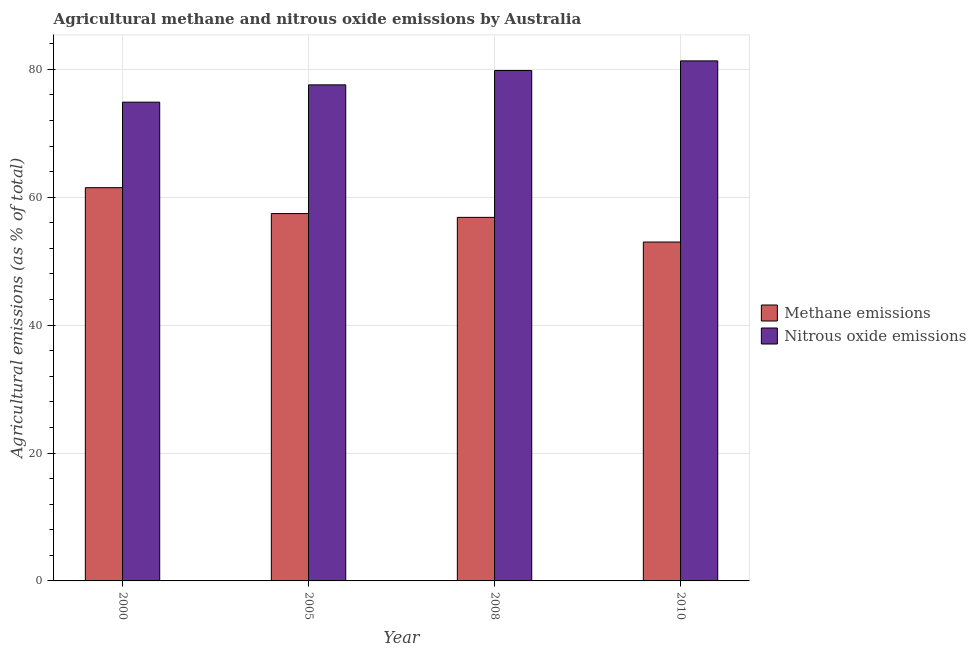Are the number of bars on each tick of the X-axis equal?
Your answer should be compact. Yes. How many bars are there on the 2nd tick from the left?
Your answer should be very brief. 2. How many bars are there on the 2nd tick from the right?
Keep it short and to the point. 2. What is the amount of nitrous oxide emissions in 2000?
Provide a short and direct response. 74.87. Across all years, what is the maximum amount of methane emissions?
Give a very brief answer. 61.5. Across all years, what is the minimum amount of nitrous oxide emissions?
Offer a terse response. 74.87. In which year was the amount of nitrous oxide emissions maximum?
Make the answer very short. 2010. What is the total amount of nitrous oxide emissions in the graph?
Ensure brevity in your answer.  313.6. What is the difference between the amount of methane emissions in 2005 and that in 2010?
Your answer should be compact. 4.45. What is the difference between the amount of nitrous oxide emissions in 2005 and the amount of methane emissions in 2010?
Your response must be concise. -3.75. What is the average amount of nitrous oxide emissions per year?
Keep it short and to the point. 78.4. In how many years, is the amount of nitrous oxide emissions greater than 48 %?
Keep it short and to the point. 4. What is the ratio of the amount of methane emissions in 2000 to that in 2008?
Keep it short and to the point. 1.08. Is the difference between the amount of methane emissions in 2008 and 2010 greater than the difference between the amount of nitrous oxide emissions in 2008 and 2010?
Ensure brevity in your answer.  No. What is the difference between the highest and the second highest amount of nitrous oxide emissions?
Ensure brevity in your answer.  1.51. What is the difference between the highest and the lowest amount of methane emissions?
Your response must be concise. 8.5. Is the sum of the amount of nitrous oxide emissions in 2000 and 2008 greater than the maximum amount of methane emissions across all years?
Your answer should be very brief. Yes. What does the 1st bar from the left in 2008 represents?
Give a very brief answer. Methane emissions. What does the 1st bar from the right in 2008 represents?
Give a very brief answer. Nitrous oxide emissions. How many bars are there?
Your response must be concise. 8. How many years are there in the graph?
Ensure brevity in your answer.  4. Are the values on the major ticks of Y-axis written in scientific E-notation?
Make the answer very short. No. Where does the legend appear in the graph?
Your answer should be compact. Center right. What is the title of the graph?
Provide a succinct answer. Agricultural methane and nitrous oxide emissions by Australia. Does "Resident" appear as one of the legend labels in the graph?
Give a very brief answer. No. What is the label or title of the Y-axis?
Keep it short and to the point. Agricultural emissions (as % of total). What is the Agricultural emissions (as % of total) of Methane emissions in 2000?
Your response must be concise. 61.5. What is the Agricultural emissions (as % of total) in Nitrous oxide emissions in 2000?
Give a very brief answer. 74.87. What is the Agricultural emissions (as % of total) of Methane emissions in 2005?
Ensure brevity in your answer.  57.45. What is the Agricultural emissions (as % of total) in Nitrous oxide emissions in 2005?
Provide a succinct answer. 77.58. What is the Agricultural emissions (as % of total) of Methane emissions in 2008?
Offer a terse response. 56.85. What is the Agricultural emissions (as % of total) in Nitrous oxide emissions in 2008?
Offer a terse response. 79.82. What is the Agricultural emissions (as % of total) in Methane emissions in 2010?
Keep it short and to the point. 53. What is the Agricultural emissions (as % of total) of Nitrous oxide emissions in 2010?
Your response must be concise. 81.33. Across all years, what is the maximum Agricultural emissions (as % of total) of Methane emissions?
Provide a succinct answer. 61.5. Across all years, what is the maximum Agricultural emissions (as % of total) in Nitrous oxide emissions?
Keep it short and to the point. 81.33. Across all years, what is the minimum Agricultural emissions (as % of total) of Methane emissions?
Your answer should be very brief. 53. Across all years, what is the minimum Agricultural emissions (as % of total) in Nitrous oxide emissions?
Your answer should be very brief. 74.87. What is the total Agricultural emissions (as % of total) of Methane emissions in the graph?
Your response must be concise. 228.8. What is the total Agricultural emissions (as % of total) of Nitrous oxide emissions in the graph?
Offer a terse response. 313.6. What is the difference between the Agricultural emissions (as % of total) of Methane emissions in 2000 and that in 2005?
Your answer should be very brief. 4.04. What is the difference between the Agricultural emissions (as % of total) in Nitrous oxide emissions in 2000 and that in 2005?
Ensure brevity in your answer.  -2.71. What is the difference between the Agricultural emissions (as % of total) of Methane emissions in 2000 and that in 2008?
Provide a succinct answer. 4.64. What is the difference between the Agricultural emissions (as % of total) of Nitrous oxide emissions in 2000 and that in 2008?
Provide a succinct answer. -4.95. What is the difference between the Agricultural emissions (as % of total) in Methane emissions in 2000 and that in 2010?
Give a very brief answer. 8.5. What is the difference between the Agricultural emissions (as % of total) of Nitrous oxide emissions in 2000 and that in 2010?
Provide a succinct answer. -6.46. What is the difference between the Agricultural emissions (as % of total) of Methane emissions in 2005 and that in 2008?
Provide a succinct answer. 0.6. What is the difference between the Agricultural emissions (as % of total) in Nitrous oxide emissions in 2005 and that in 2008?
Give a very brief answer. -2.24. What is the difference between the Agricultural emissions (as % of total) of Methane emissions in 2005 and that in 2010?
Give a very brief answer. 4.45. What is the difference between the Agricultural emissions (as % of total) of Nitrous oxide emissions in 2005 and that in 2010?
Offer a very short reply. -3.75. What is the difference between the Agricultural emissions (as % of total) of Methane emissions in 2008 and that in 2010?
Give a very brief answer. 3.86. What is the difference between the Agricultural emissions (as % of total) of Nitrous oxide emissions in 2008 and that in 2010?
Your answer should be compact. -1.51. What is the difference between the Agricultural emissions (as % of total) of Methane emissions in 2000 and the Agricultural emissions (as % of total) of Nitrous oxide emissions in 2005?
Your answer should be very brief. -16.08. What is the difference between the Agricultural emissions (as % of total) in Methane emissions in 2000 and the Agricultural emissions (as % of total) in Nitrous oxide emissions in 2008?
Your response must be concise. -18.32. What is the difference between the Agricultural emissions (as % of total) in Methane emissions in 2000 and the Agricultural emissions (as % of total) in Nitrous oxide emissions in 2010?
Make the answer very short. -19.83. What is the difference between the Agricultural emissions (as % of total) in Methane emissions in 2005 and the Agricultural emissions (as % of total) in Nitrous oxide emissions in 2008?
Keep it short and to the point. -22.37. What is the difference between the Agricultural emissions (as % of total) of Methane emissions in 2005 and the Agricultural emissions (as % of total) of Nitrous oxide emissions in 2010?
Provide a short and direct response. -23.88. What is the difference between the Agricultural emissions (as % of total) of Methane emissions in 2008 and the Agricultural emissions (as % of total) of Nitrous oxide emissions in 2010?
Keep it short and to the point. -24.47. What is the average Agricultural emissions (as % of total) in Methane emissions per year?
Keep it short and to the point. 57.2. What is the average Agricultural emissions (as % of total) in Nitrous oxide emissions per year?
Ensure brevity in your answer.  78.4. In the year 2000, what is the difference between the Agricultural emissions (as % of total) in Methane emissions and Agricultural emissions (as % of total) in Nitrous oxide emissions?
Offer a very short reply. -13.38. In the year 2005, what is the difference between the Agricultural emissions (as % of total) in Methane emissions and Agricultural emissions (as % of total) in Nitrous oxide emissions?
Give a very brief answer. -20.13. In the year 2008, what is the difference between the Agricultural emissions (as % of total) in Methane emissions and Agricultural emissions (as % of total) in Nitrous oxide emissions?
Give a very brief answer. -22.96. In the year 2010, what is the difference between the Agricultural emissions (as % of total) in Methane emissions and Agricultural emissions (as % of total) in Nitrous oxide emissions?
Provide a succinct answer. -28.33. What is the ratio of the Agricultural emissions (as % of total) in Methane emissions in 2000 to that in 2005?
Make the answer very short. 1.07. What is the ratio of the Agricultural emissions (as % of total) of Nitrous oxide emissions in 2000 to that in 2005?
Ensure brevity in your answer.  0.97. What is the ratio of the Agricultural emissions (as % of total) of Methane emissions in 2000 to that in 2008?
Your answer should be very brief. 1.08. What is the ratio of the Agricultural emissions (as % of total) in Nitrous oxide emissions in 2000 to that in 2008?
Offer a very short reply. 0.94. What is the ratio of the Agricultural emissions (as % of total) in Methane emissions in 2000 to that in 2010?
Offer a terse response. 1.16. What is the ratio of the Agricultural emissions (as % of total) in Nitrous oxide emissions in 2000 to that in 2010?
Give a very brief answer. 0.92. What is the ratio of the Agricultural emissions (as % of total) of Methane emissions in 2005 to that in 2008?
Keep it short and to the point. 1.01. What is the ratio of the Agricultural emissions (as % of total) in Nitrous oxide emissions in 2005 to that in 2008?
Your response must be concise. 0.97. What is the ratio of the Agricultural emissions (as % of total) of Methane emissions in 2005 to that in 2010?
Your response must be concise. 1.08. What is the ratio of the Agricultural emissions (as % of total) in Nitrous oxide emissions in 2005 to that in 2010?
Offer a very short reply. 0.95. What is the ratio of the Agricultural emissions (as % of total) in Methane emissions in 2008 to that in 2010?
Offer a terse response. 1.07. What is the ratio of the Agricultural emissions (as % of total) of Nitrous oxide emissions in 2008 to that in 2010?
Your answer should be very brief. 0.98. What is the difference between the highest and the second highest Agricultural emissions (as % of total) in Methane emissions?
Your response must be concise. 4.04. What is the difference between the highest and the second highest Agricultural emissions (as % of total) of Nitrous oxide emissions?
Give a very brief answer. 1.51. What is the difference between the highest and the lowest Agricultural emissions (as % of total) of Methane emissions?
Offer a very short reply. 8.5. What is the difference between the highest and the lowest Agricultural emissions (as % of total) in Nitrous oxide emissions?
Your answer should be very brief. 6.46. 